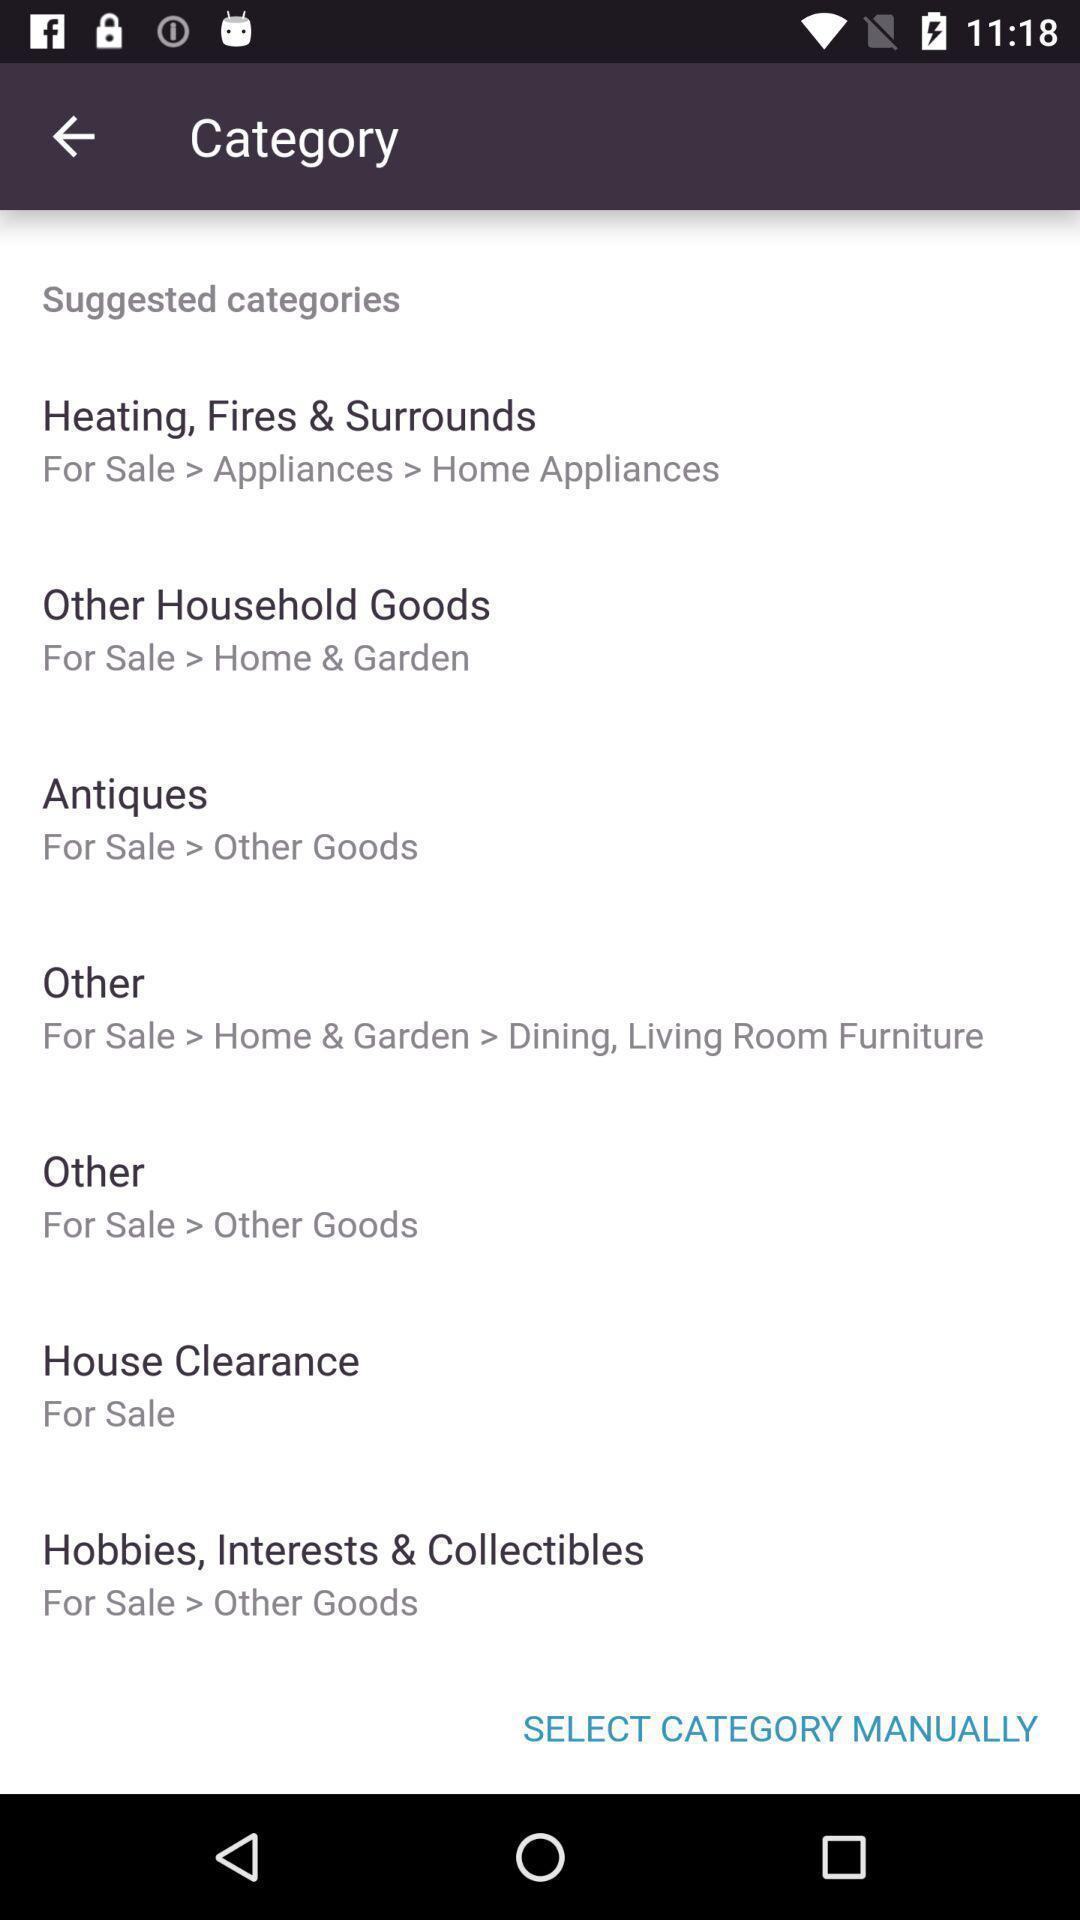Give me a summary of this screen capture. Page showing different options under category on an app. 